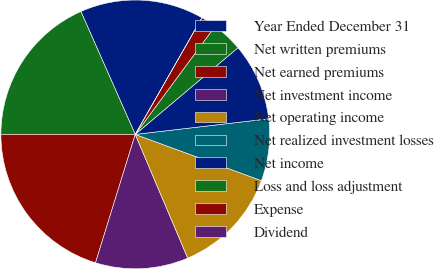Convert chart to OTSL. <chart><loc_0><loc_0><loc_500><loc_500><pie_chart><fcel>Year Ended December 31<fcel>Net written premiums<fcel>Net earned premiums<fcel>Net investment income<fcel>Net operating income<fcel>Net realized investment losses<fcel>Net income<fcel>Loss and loss adjustment<fcel>Expense<fcel>Dividend<nl><fcel>14.89%<fcel>18.36%<fcel>20.22%<fcel>11.16%<fcel>13.02%<fcel>7.44%<fcel>9.3%<fcel>3.72%<fcel>1.86%<fcel>0.0%<nl></chart> 